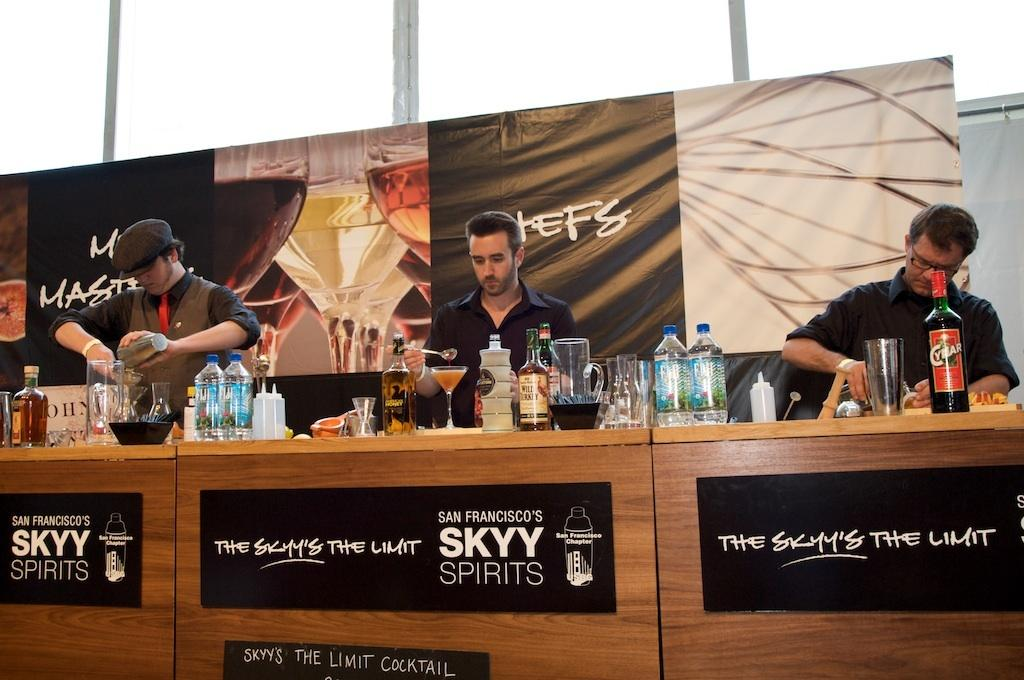How many people are in the image? There are three people in the image. Where are the people located in the image? The people are behind a desk. What objects can be seen on the desk? There are jars, glasses, and bottles on the desk, as well as other unspecified items. What type of parcel is being delivered to the people in the image? There is no parcel present in the image; it only shows three people behind a desk with various objects on it. 